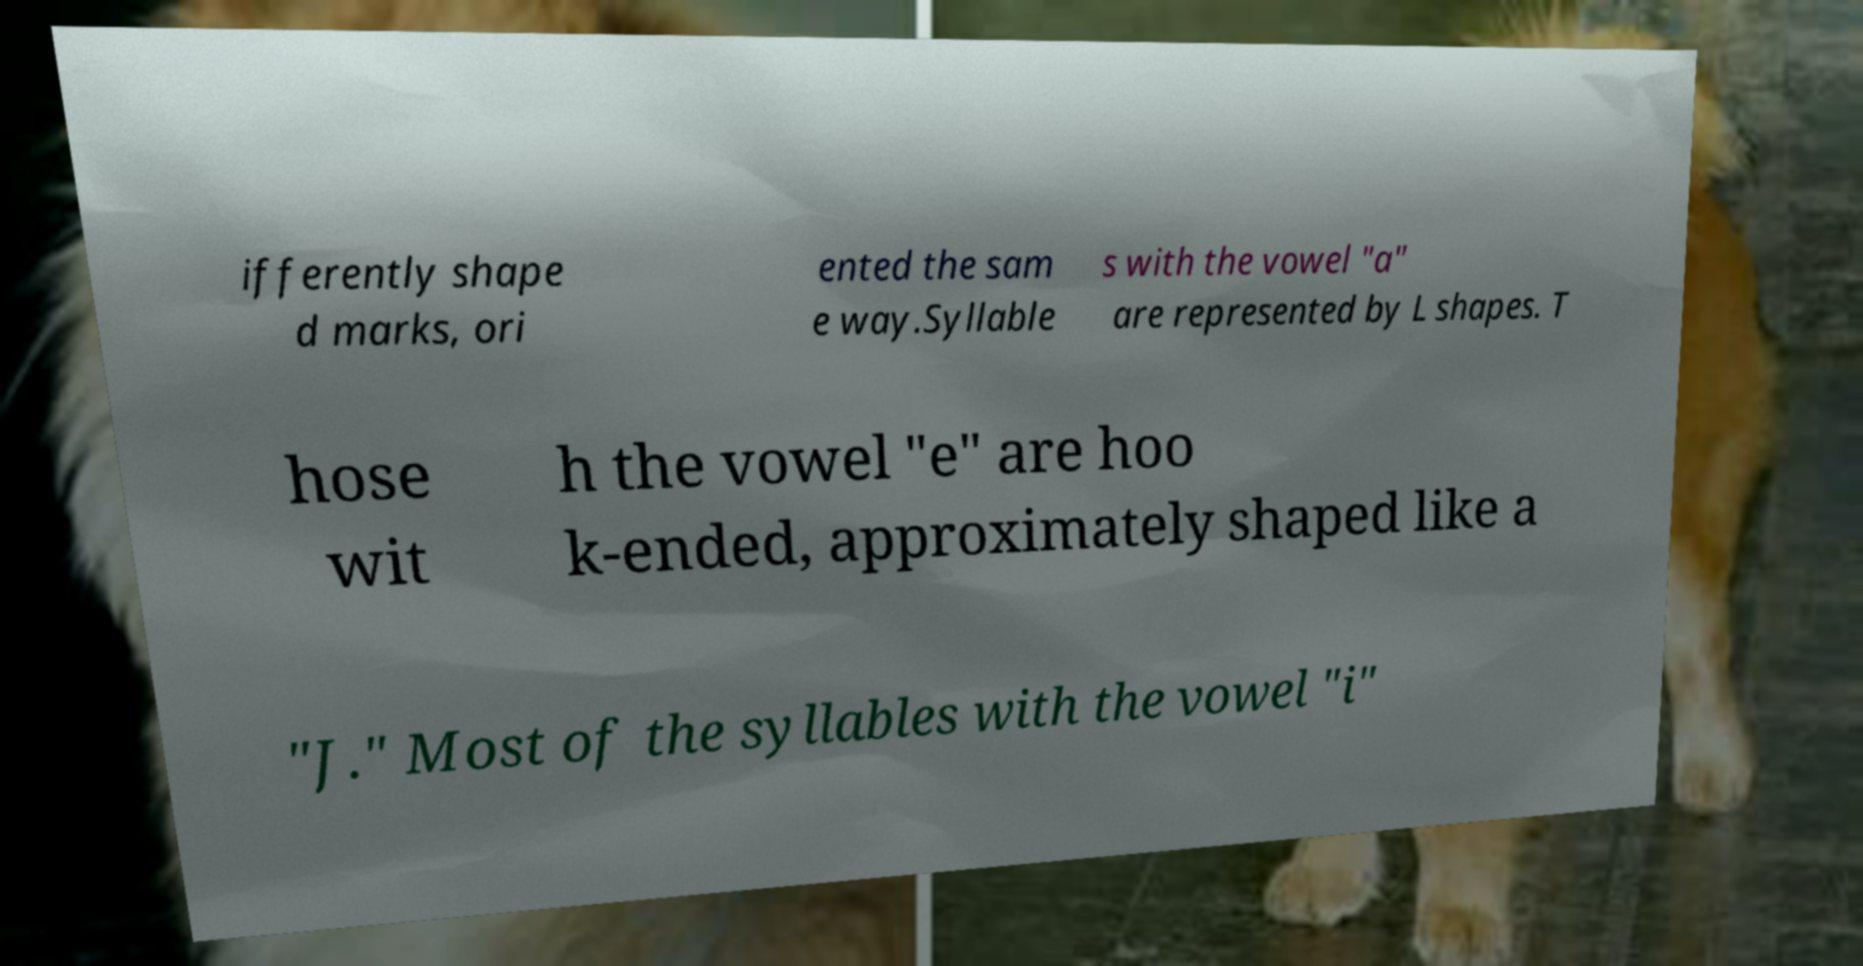Can you read and provide the text displayed in the image?This photo seems to have some interesting text. Can you extract and type it out for me? ifferently shape d marks, ori ented the sam e way.Syllable s with the vowel "a" are represented by L shapes. T hose wit h the vowel "e" are hoo k-ended, approximately shaped like a "J." Most of the syllables with the vowel "i" 